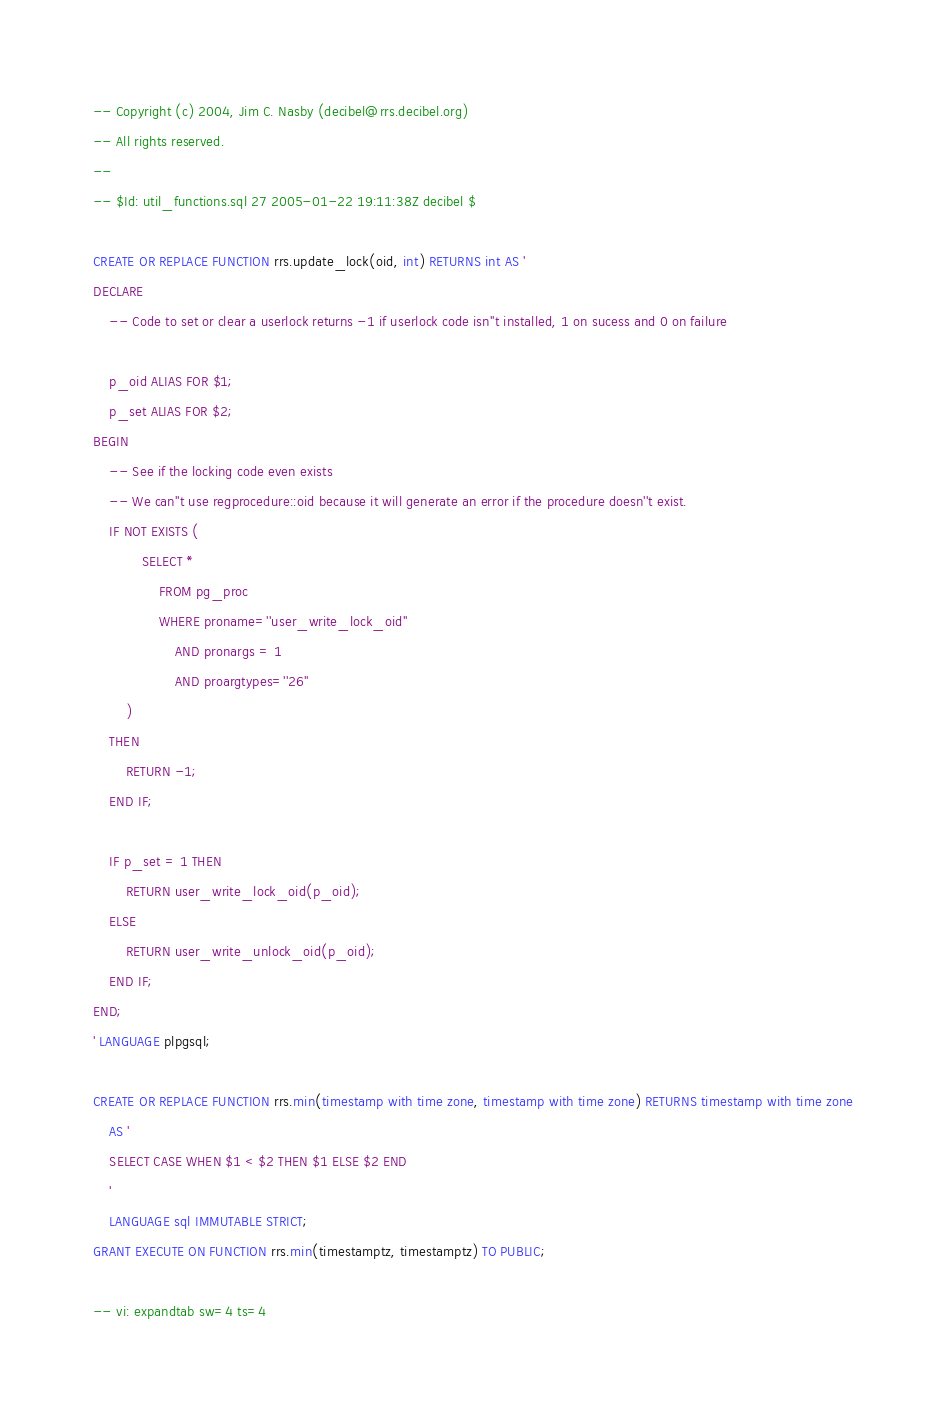Convert code to text. <code><loc_0><loc_0><loc_500><loc_500><_SQL_>-- Copyright (c) 2004, Jim C. Nasby (decibel@rrs.decibel.org)
-- All rights reserved.
--
-- $Id: util_functions.sql 27 2005-01-22 19:11:38Z decibel $

CREATE OR REPLACE FUNCTION rrs.update_lock(oid, int) RETURNS int AS '
DECLARE
    -- Code to set or clear a userlock returns -1 if userlock code isn''t installed, 1 on sucess and 0 on failure

    p_oid ALIAS FOR $1;
    p_set ALIAS FOR $2;
BEGIN
    -- See if the locking code even exists
    -- We can''t use regprocedure::oid because it will generate an error if the procedure doesn''t exist.
    IF NOT EXISTS (
            SELECT *
                FROM pg_proc
                WHERE proname=''user_write_lock_oid''
                    AND pronargs = 1
                    AND proargtypes=''26''
        )
    THEN
        RETURN -1;
    END IF;

    IF p_set = 1 THEN
        RETURN user_write_lock_oid(p_oid);
    ELSE
        RETURN user_write_unlock_oid(p_oid);
    END IF;
END;
' LANGUAGE plpgsql;

CREATE OR REPLACE FUNCTION rrs.min(timestamp with time zone, timestamp with time zone) RETURNS timestamp with time zone
    AS '
    SELECT CASE WHEN $1 < $2 THEN $1 ELSE $2 END
    '
    LANGUAGE sql IMMUTABLE STRICT;
GRANT EXECUTE ON FUNCTION rrs.min(timestamptz, timestamptz) TO PUBLIC;

-- vi: expandtab sw=4 ts=4
</code> 